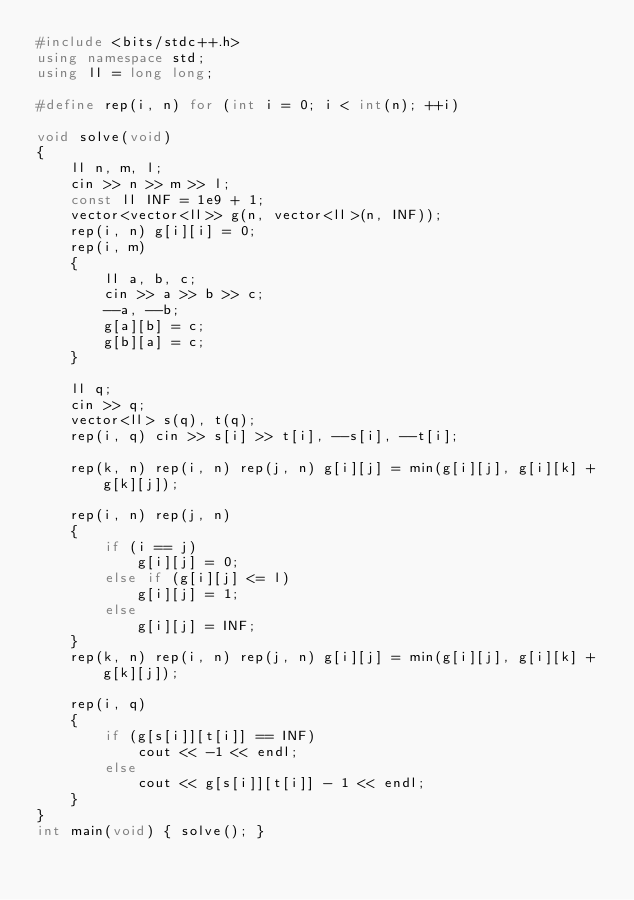<code> <loc_0><loc_0><loc_500><loc_500><_C++_>#include <bits/stdc++.h>
using namespace std;
using ll = long long;

#define rep(i, n) for (int i = 0; i < int(n); ++i)

void solve(void)
{
    ll n, m, l;
    cin >> n >> m >> l;
    const ll INF = 1e9 + 1;
    vector<vector<ll>> g(n, vector<ll>(n, INF));
    rep(i, n) g[i][i] = 0;
    rep(i, m)
    {
        ll a, b, c;
        cin >> a >> b >> c;
        --a, --b;
        g[a][b] = c;
        g[b][a] = c;
    }

    ll q;
    cin >> q;
    vector<ll> s(q), t(q);
    rep(i, q) cin >> s[i] >> t[i], --s[i], --t[i];

    rep(k, n) rep(i, n) rep(j, n) g[i][j] = min(g[i][j], g[i][k] + g[k][j]);

    rep(i, n) rep(j, n)
    {
        if (i == j)
            g[i][j] = 0;
        else if (g[i][j] <= l)
            g[i][j] = 1;
        else
            g[i][j] = INF;
    }
    rep(k, n) rep(i, n) rep(j, n) g[i][j] = min(g[i][j], g[i][k] + g[k][j]);

    rep(i, q)
    {
        if (g[s[i]][t[i]] == INF)
            cout << -1 << endl;
        else
            cout << g[s[i]][t[i]] - 1 << endl;
    }
}
int main(void) { solve(); }
</code> 